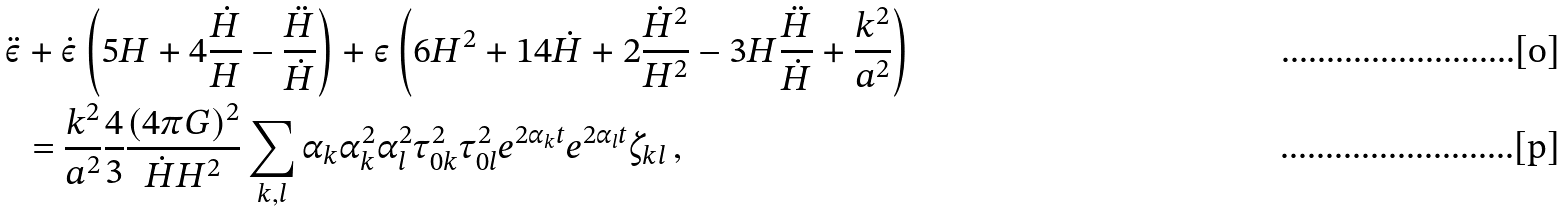<formula> <loc_0><loc_0><loc_500><loc_500>\ddot { \varepsilon } & + \dot { \varepsilon } \left ( 5 H + 4 \frac { \dot { H } } { H } - \frac { \ddot { H } } { \dot { H } } \right ) + \varepsilon \left ( 6 H ^ { 2 } + 1 4 \dot { H } + 2 \frac { \dot { H } ^ { 2 } } { H ^ { 2 } } - 3 H \frac { \ddot { H } } { \dot { H } } + \frac { k ^ { 2 } } { a ^ { 2 } } \right ) \\ & = \frac { k ^ { 2 } } { a ^ { 2 } } \frac { 4 } { 3 } \frac { ( 4 \pi G ) ^ { 2 } } { \dot { H } H ^ { 2 } } \sum _ { k , l } \alpha _ { k } \alpha ^ { 2 } _ { k } \alpha ^ { 2 } _ { l } \tau ^ { 2 } _ { 0 k } \tau ^ { 2 } _ { 0 l } e ^ { 2 \alpha _ { k } t } e ^ { 2 \alpha _ { l } t } \zeta _ { k l } \, ,</formula> 